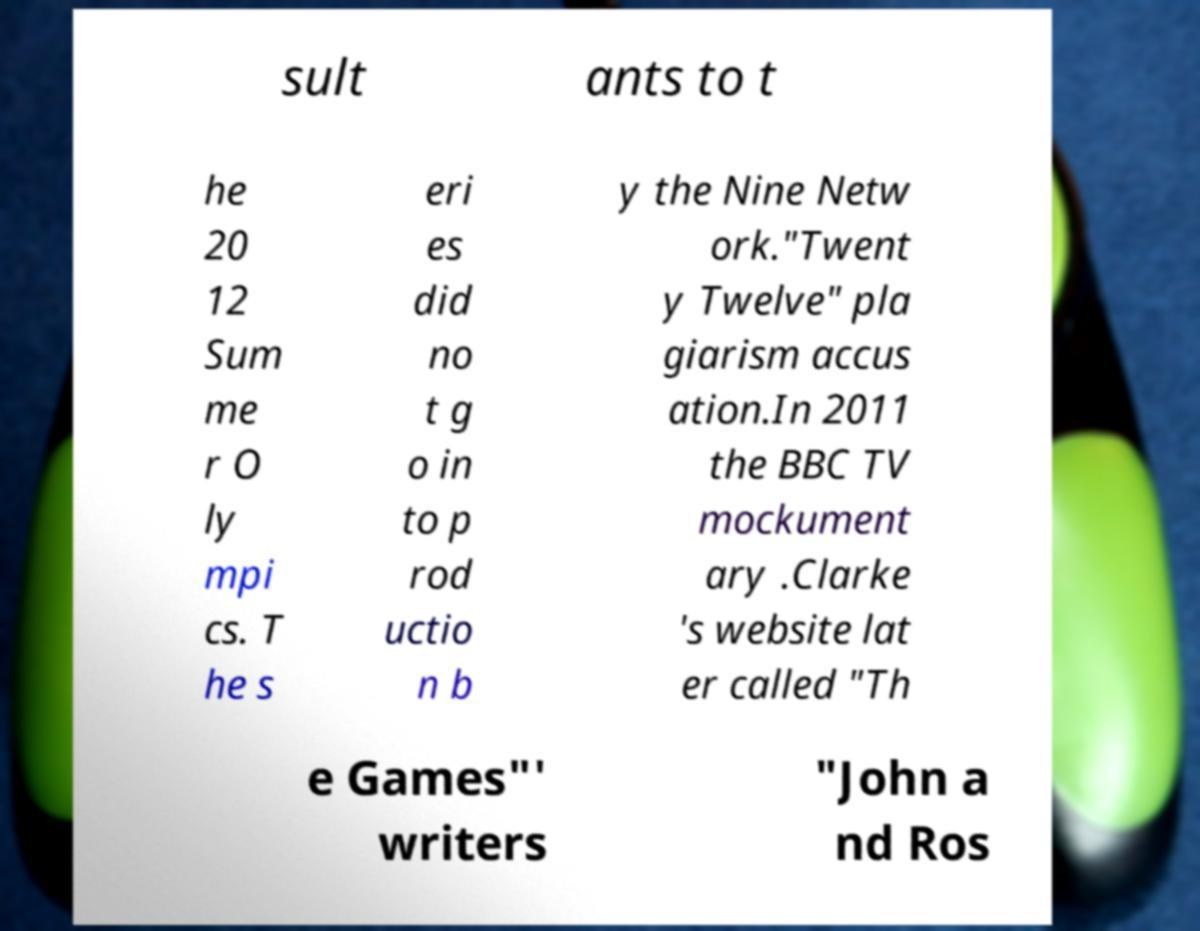What messages or text are displayed in this image? I need them in a readable, typed format. sult ants to t he 20 12 Sum me r O ly mpi cs. T he s eri es did no t g o in to p rod uctio n b y the Nine Netw ork."Twent y Twelve" pla giarism accus ation.In 2011 the BBC TV mockument ary .Clarke 's website lat er called "Th e Games"' writers "John a nd Ros 